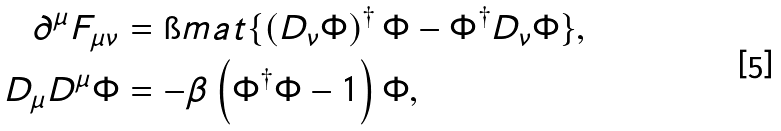Convert formula to latex. <formula><loc_0><loc_0><loc_500><loc_500>\partial ^ { \mu } F _ { \mu \nu } & = \i m a t \{ \left ( D _ { \nu } \Phi \right ) ^ { \dagger } \Phi - \Phi ^ { \dagger } D _ { \nu } \Phi \} , \\ D _ { \mu } D ^ { \mu } \Phi & = - \beta \left ( \Phi ^ { \dagger } \Phi - 1 \right ) \Phi ,</formula> 